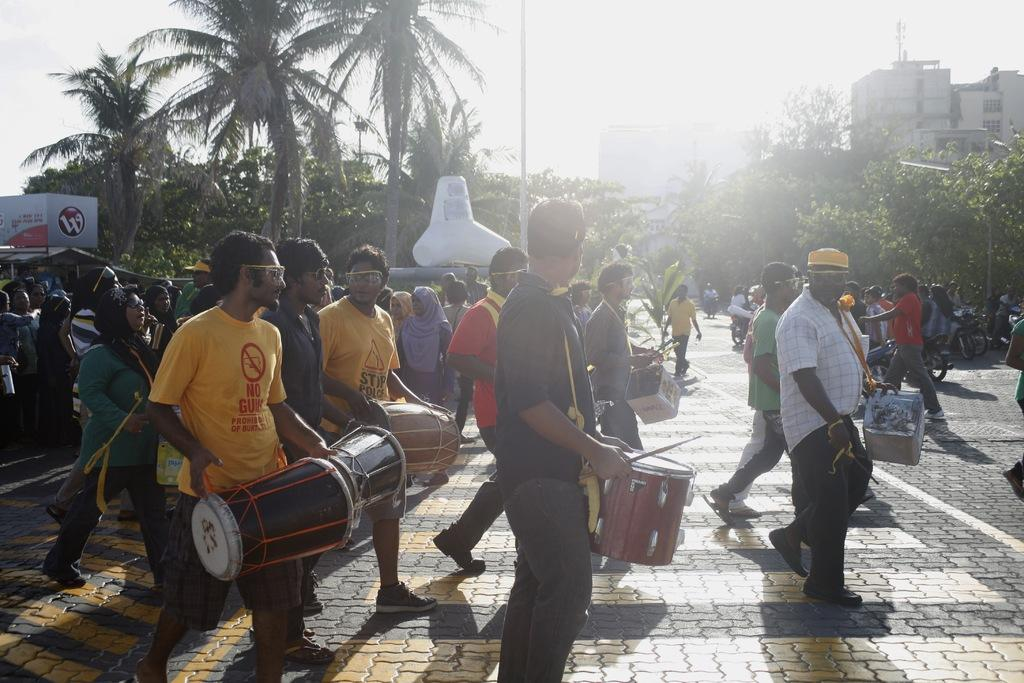How many people are present in the image? There are many people in the image. What can be seen in the background of the image? There are trees, a building, and the sky visible in the background of the image. Can you describe the person on the right side of the image? The person on the right side of the image is wearing a shirt, trousers, and shoes. What type of seed is being planted in the pan by the person in the image? There is no pan or seed present in the image. How does the carriage in the image transport the people? There is no carriage present in the image. 